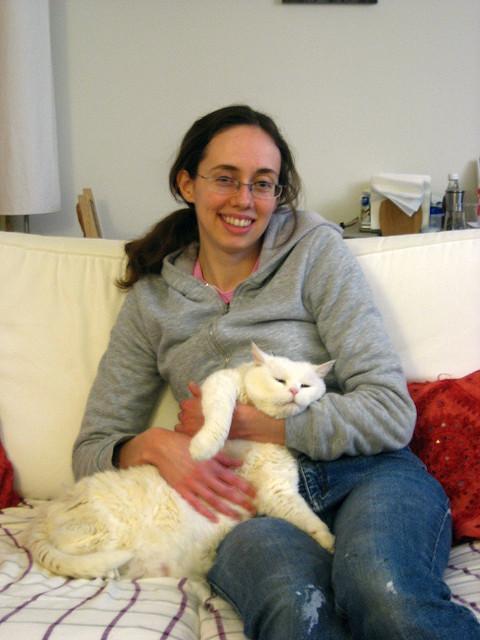Are the women's jeans clean or dirty?
Keep it brief. Dirty. What time is it?
Concise answer only. Noon. Is this woman sad?
Keep it brief. No. What is the woman holding?
Give a very brief answer. Cat. What is this animal holding?
Quick response, please. Cat. 